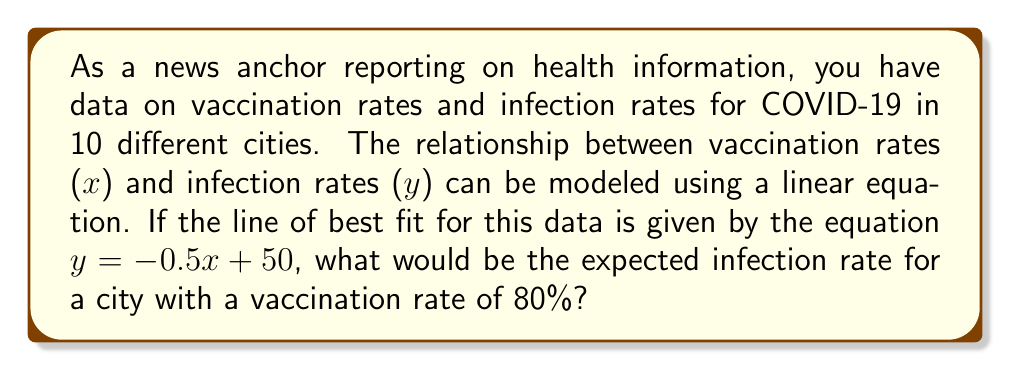Could you help me with this problem? To solve this problem, we need to use the given linear equation and substitute the known vaccination rate. Let's break it down step-by-step:

1. The linear equation is given as:
   $y = -0.5x + 50$

   Where:
   $y$ represents the infection rate
   $x$ represents the vaccination rate

2. We're asked to find the infection rate when the vaccination rate is 80%. So, we need to substitute $x = 80$ into the equation:

   $y = -0.5(80) + 50$

3. Now, let's solve this equation:
   $y = -40 + 50$
   $y = 10$

Therefore, for a city with a vaccination rate of 80%, the expected infection rate would be 10%.

This linear relationship suggests that as vaccination rates increase, infection rates decrease. The slope of -0.5 indicates that for every 1% increase in vaccination rate, the infection rate is expected to decrease by 0.5%.
Answer: The expected infection rate for a city with a vaccination rate of 80% is 10%. 